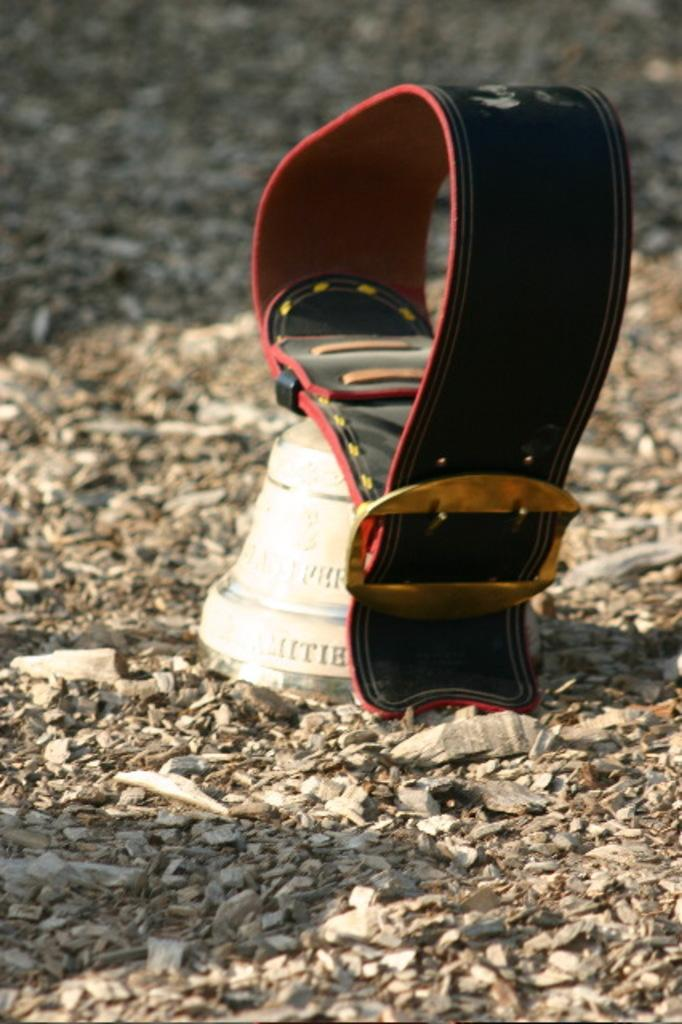What is the main object in the center of the image? There is a belt in the center of the image, along with a white color object. What can be seen surrounding the belt and white color object? Stones are present around the belt and white color object. How would you describe the top part of the image? The top of the image is blurred. What type of stage is visible in the image? There is no stage present in the image. What advertisement can be seen on the belt in the image? There is no advertisement visible on the belt in the image. 